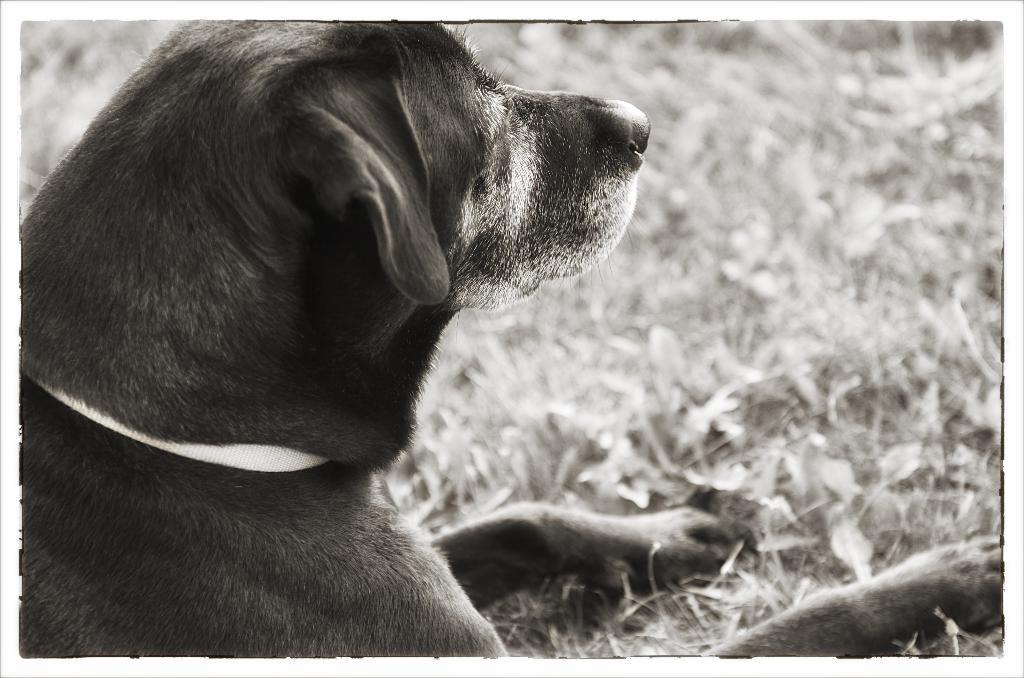What type of animal can be seen in the picture? There is a dog in the picture. What natural elements are present on the right side of the image? There is grass and leaves on the right side of the image. Can you describe the background of the image? The background of the image is blurred. How many snakes are slithering on the hill in the image? There are no snakes or hills present in the image; it features a dog and blurred background. 